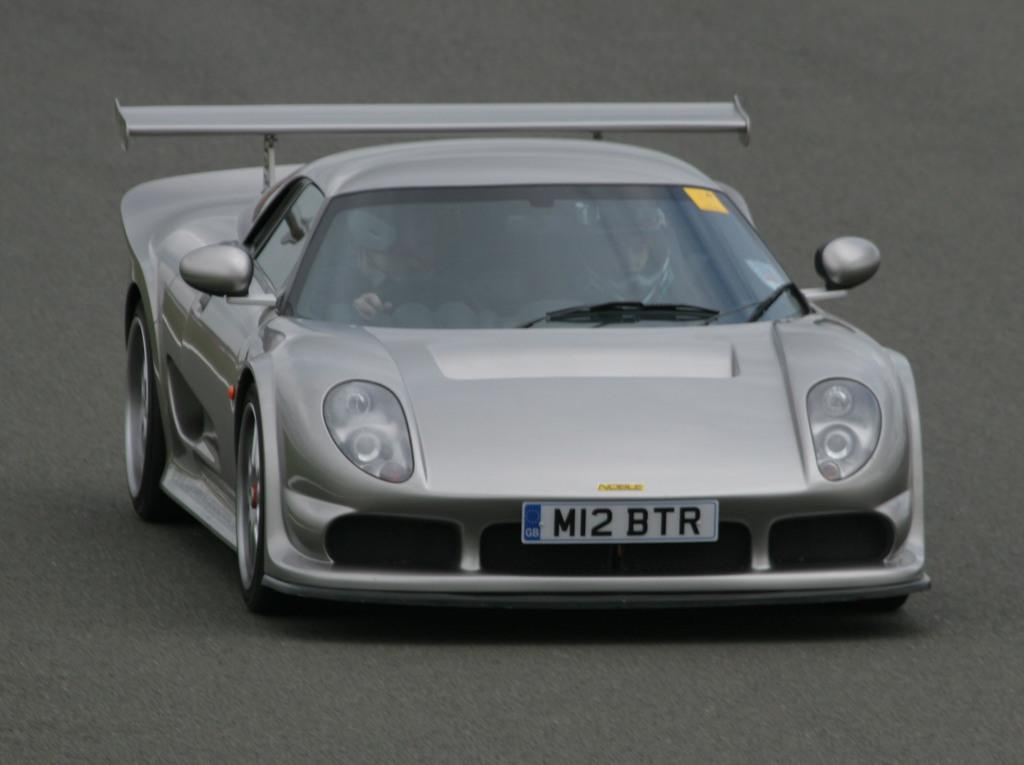What is the main subject of the image? The main subject of the image is a car. What is the car doing in the image? The car is moving on the road in the image. Are there any people inside the car? Yes, there are persons sitting inside the car. What additional information can be seen on the car? There is some text and numbers written on the car. What type of plantation can be seen in the image? There is no plantation present in the image; it features a moving car with people inside. What is the speed limit of the car in the image? The speed limit cannot be determined from the image alone, as it only shows a moving car with no indication of the speed. 